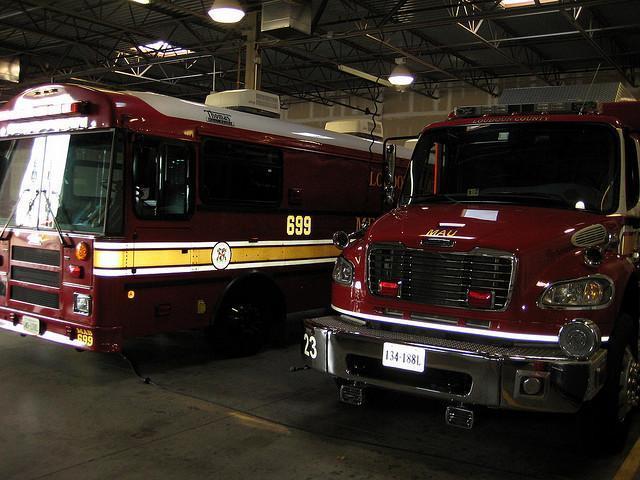Is the caption "The bus is in front of the truck." a true representation of the image?
Answer yes or no. No. 